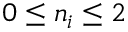<formula> <loc_0><loc_0><loc_500><loc_500>{ 0 \leq n _ { i } \leq 2 }</formula> 